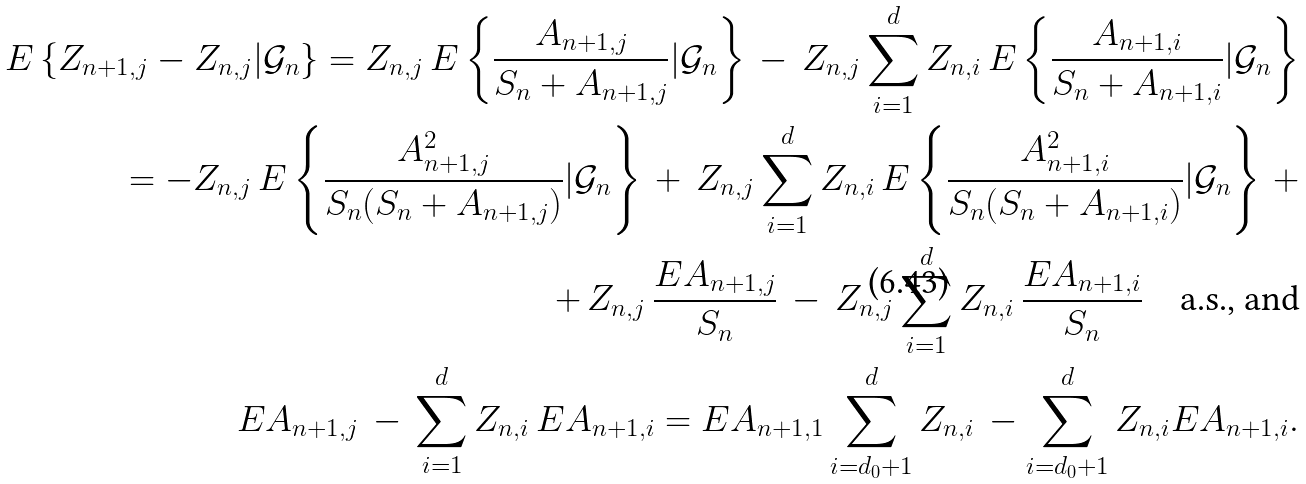<formula> <loc_0><loc_0><loc_500><loc_500>E \left \{ Z _ { n + 1 , j } - Z _ { n , j } | \mathcal { G } _ { n } \right \} = Z _ { n , j } \, E \left \{ \frac { A _ { n + 1 , j } } { S _ { n } + A _ { n + 1 , j } } | \mathcal { G } _ { n } \right \} \, - \, Z _ { n , j } \sum _ { i = 1 } ^ { d } Z _ { n , i } \, E \left \{ \frac { A _ { n + 1 , i } } { S _ { n } + A _ { n + 1 , i } } | \mathcal { G } _ { n } \right \} \\ = - Z _ { n , j } \, E \left \{ \frac { A _ { n + 1 , j } ^ { 2 } } { S _ { n } ( S _ { n } + A _ { n + 1 , j } ) } | \mathcal { G } _ { n } \right \} \, + \, Z _ { n , j } \sum _ { i = 1 } ^ { d } Z _ { n , i } \, E \left \{ \frac { A _ { n + 1 , i } ^ { 2 } } { S _ { n } ( S _ { n } + A _ { n + 1 , i } ) } | \mathcal { G } _ { n } \right \} \, + \\ + \, Z _ { n , j } \, \frac { E A _ { n + 1 , j } } { S _ { n } } \, - \, Z _ { n , j } \sum _ { i = 1 } ^ { d } Z _ { n , i } \, \frac { E A _ { n + 1 , i } } { S _ { n } } \quad \text {a.s., and} \\ E A _ { n + 1 , j } \, - \, \sum _ { i = 1 } ^ { d } Z _ { n , i } \, E A _ { n + 1 , i } = E A _ { n + 1 , 1 } \sum _ { i = d _ { 0 } + 1 } ^ { d } Z _ { n , i } \, - \sum _ { i = d _ { 0 } + 1 } ^ { d } Z _ { n , i } E A _ { n + 1 , i } .</formula> 